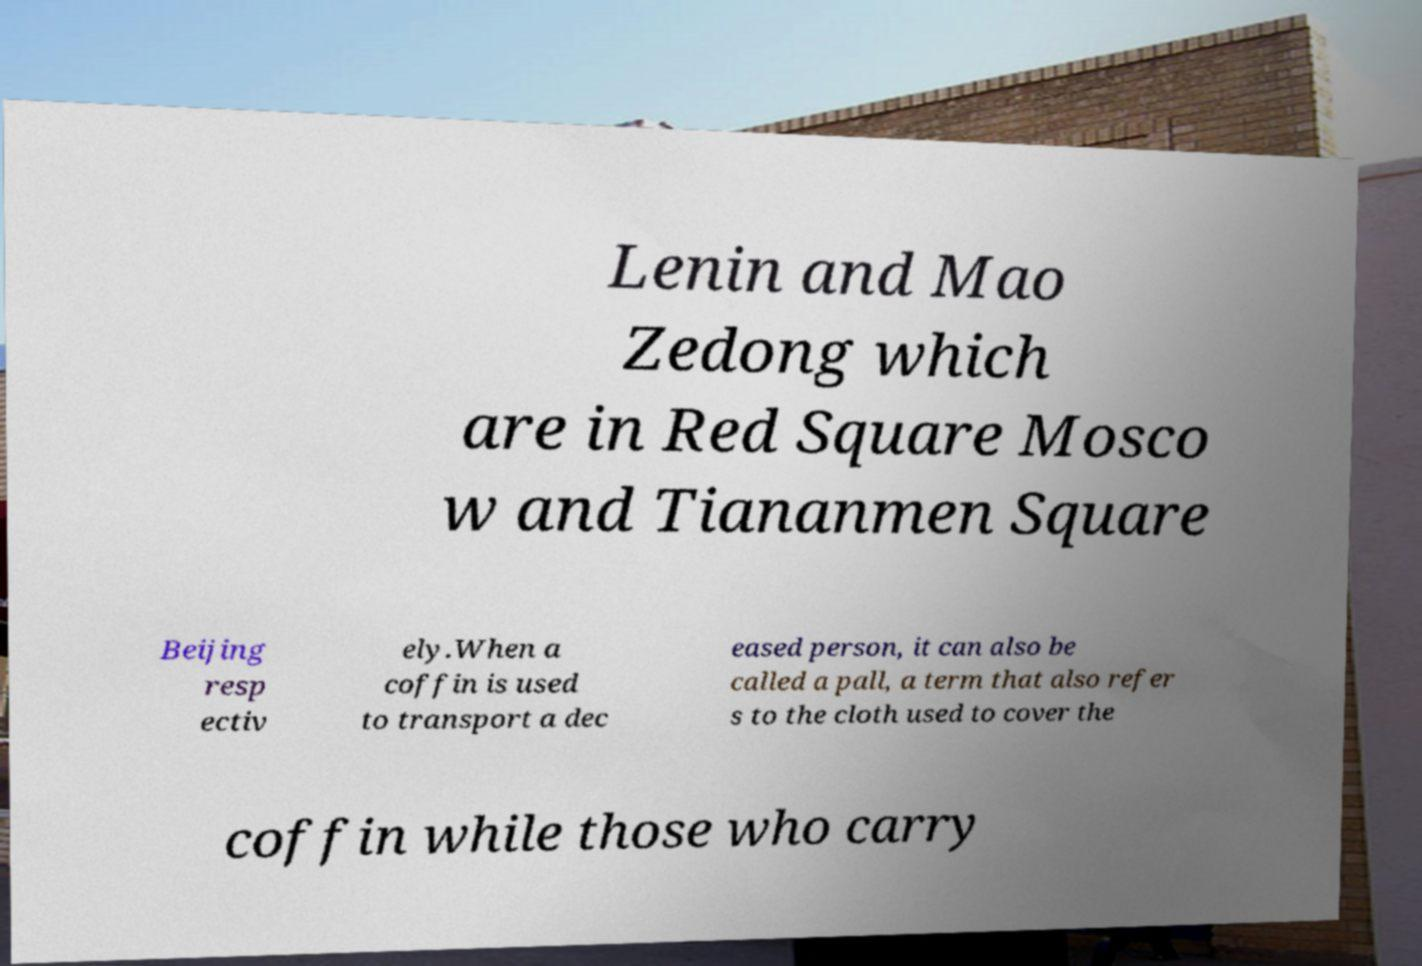Can you read and provide the text displayed in the image?This photo seems to have some interesting text. Can you extract and type it out for me? Lenin and Mao Zedong which are in Red Square Mosco w and Tiananmen Square Beijing resp ectiv ely.When a coffin is used to transport a dec eased person, it can also be called a pall, a term that also refer s to the cloth used to cover the coffin while those who carry 